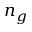Convert formula to latex. <formula><loc_0><loc_0><loc_500><loc_500>n _ { g }</formula> 